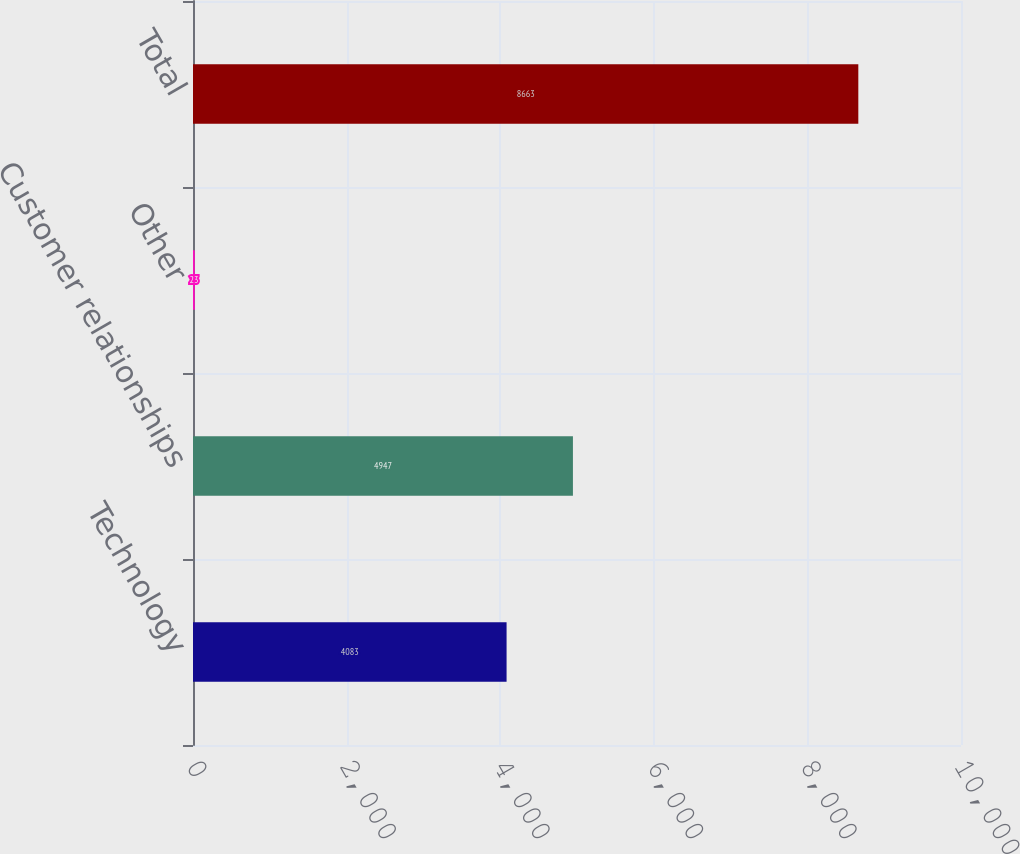Convert chart to OTSL. <chart><loc_0><loc_0><loc_500><loc_500><bar_chart><fcel>Technology<fcel>Customer relationships<fcel>Other<fcel>Total<nl><fcel>4083<fcel>4947<fcel>23<fcel>8663<nl></chart> 